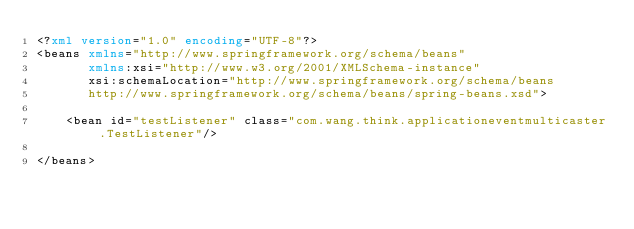Convert code to text. <code><loc_0><loc_0><loc_500><loc_500><_XML_><?xml version="1.0" encoding="UTF-8"?>
<beans xmlns="http://www.springframework.org/schema/beans"
       xmlns:xsi="http://www.w3.org/2001/XMLSchema-instance"
       xsi:schemaLocation="http://www.springframework.org/schema/beans
       http://www.springframework.org/schema/beans/spring-beans.xsd">

    <bean id="testListener" class="com.wang.think.applicationeventmulticaster.TestListener"/>

</beans></code> 